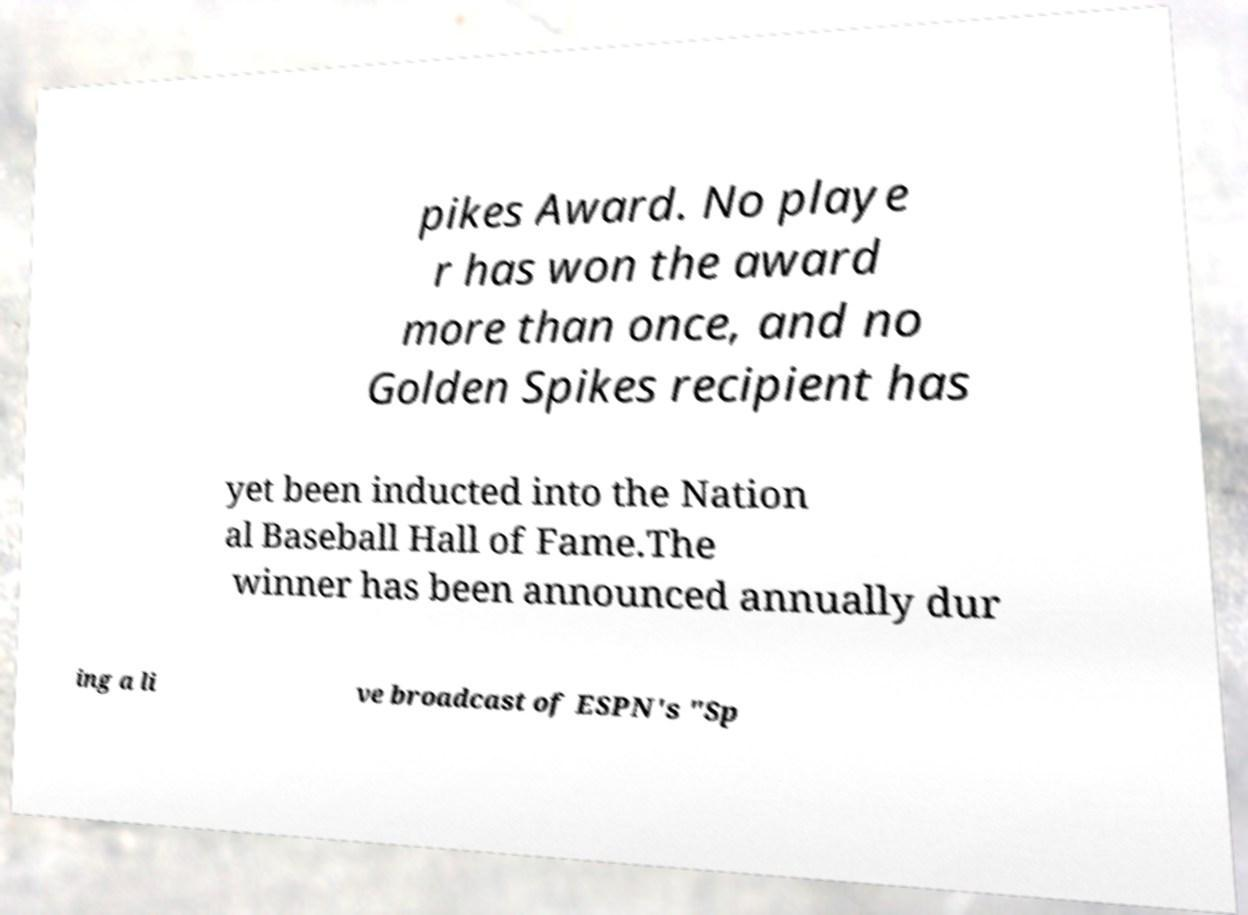For documentation purposes, I need the text within this image transcribed. Could you provide that? pikes Award. No playe r has won the award more than once, and no Golden Spikes recipient has yet been inducted into the Nation al Baseball Hall of Fame.The winner has been announced annually dur ing a li ve broadcast of ESPN's "Sp 